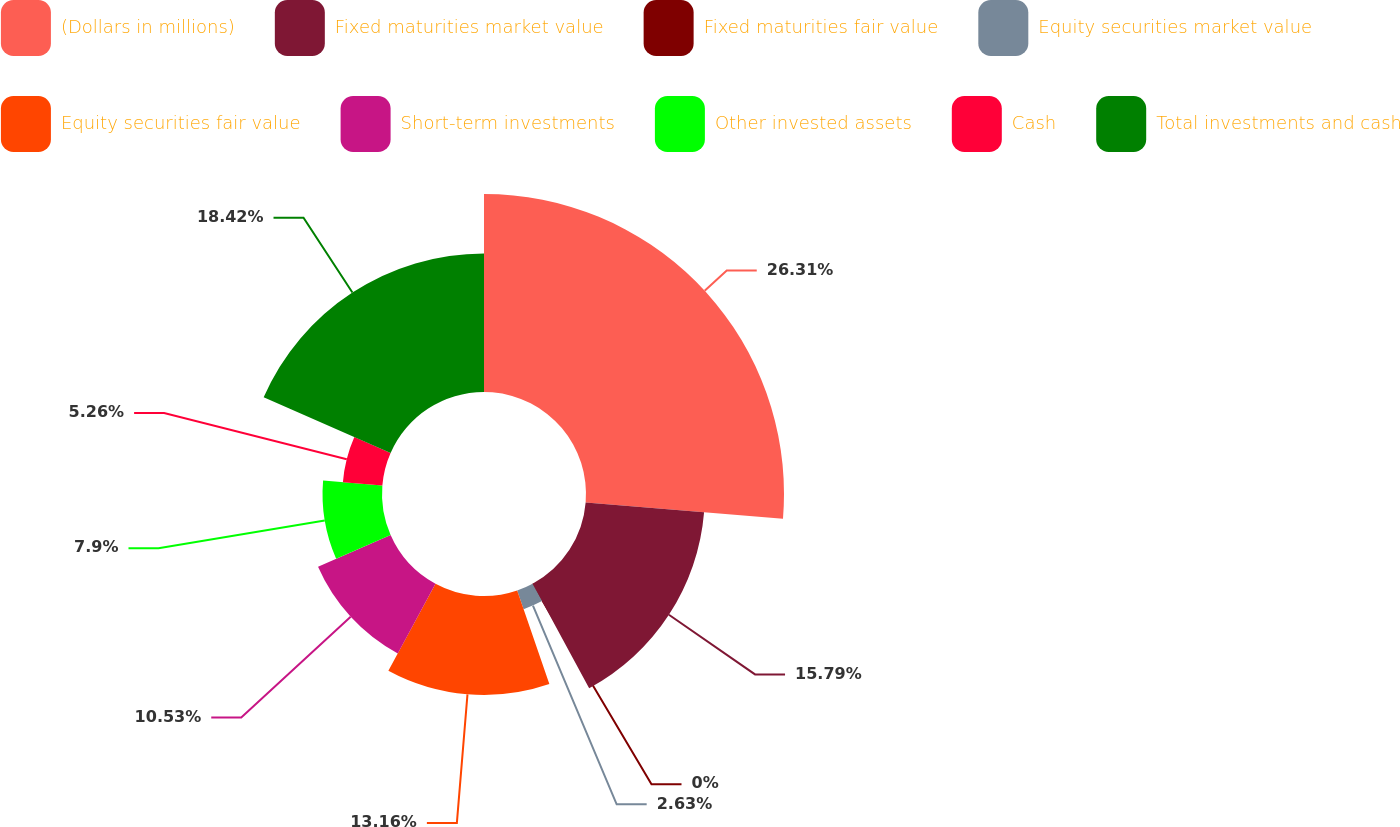Convert chart. <chart><loc_0><loc_0><loc_500><loc_500><pie_chart><fcel>(Dollars in millions)<fcel>Fixed maturities market value<fcel>Fixed maturities fair value<fcel>Equity securities market value<fcel>Equity securities fair value<fcel>Short-term investments<fcel>Other invested assets<fcel>Cash<fcel>Total investments and cash<nl><fcel>26.31%<fcel>15.79%<fcel>0.0%<fcel>2.63%<fcel>13.16%<fcel>10.53%<fcel>7.9%<fcel>5.26%<fcel>18.42%<nl></chart> 